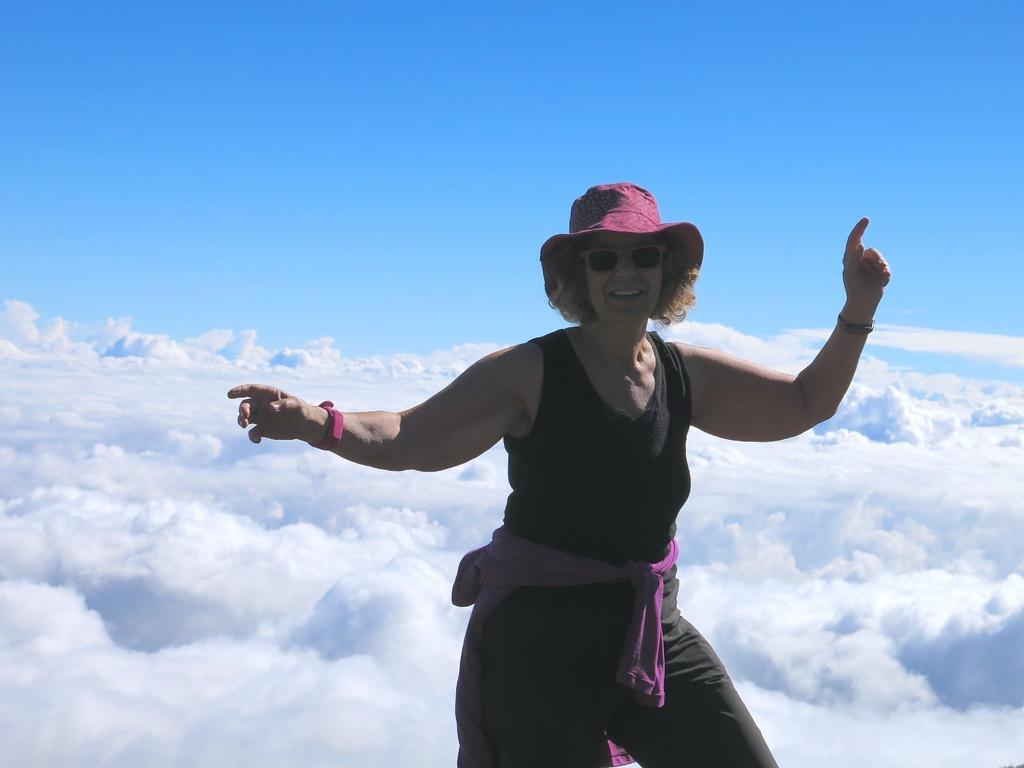Describe this image in one or two sentences. In this image, we can see a woman is dancing and smiling. In the background, we can see the clouds and sky. 